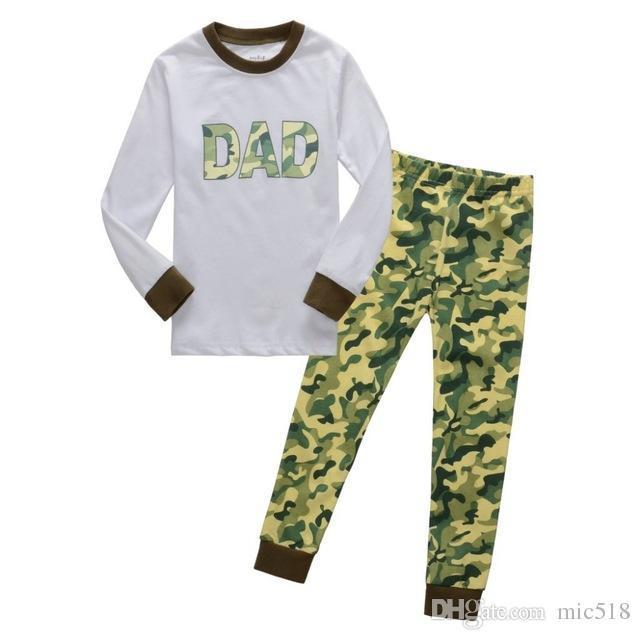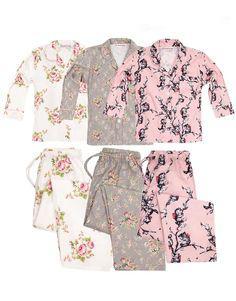The first image is the image on the left, the second image is the image on the right. Considering the images on both sides, is "An image shows a set of loungewear that features a mostly solid-colored long-sleeved top and a coordinating pair of patterned leggings." valid? Answer yes or no. Yes. The first image is the image on the left, the second image is the image on the right. Assess this claim about the two images: "A two-piece pajama set in one image has a pullover top with applique in the chest area, with wide cuffs on the shirt sleeves and pant legs.". Correct or not? Answer yes or no. Yes. 